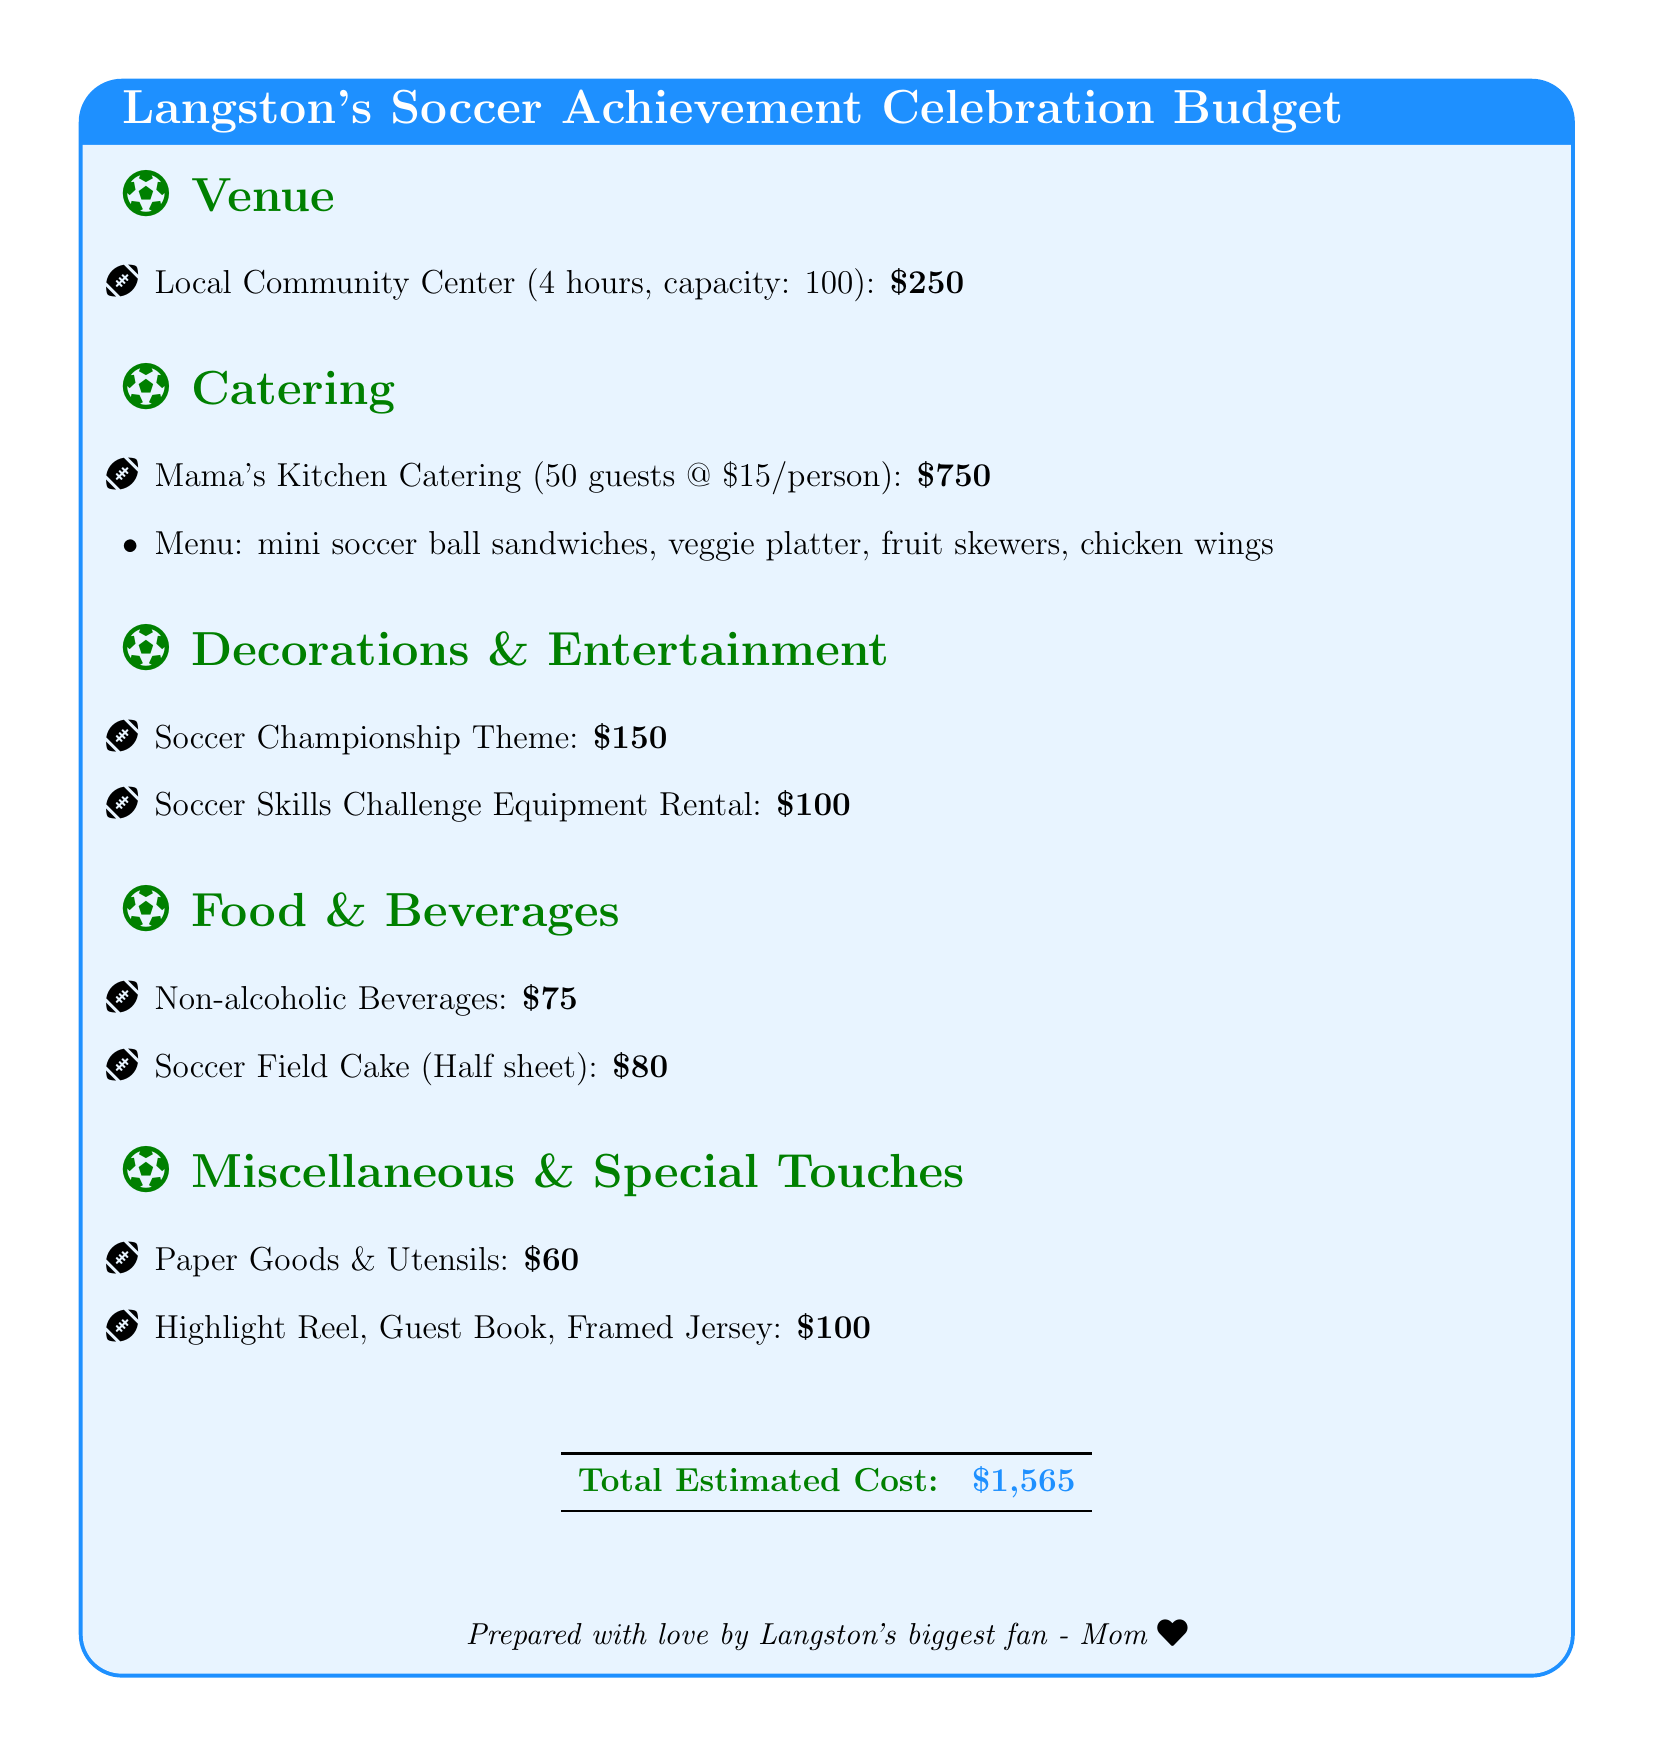What is the estimated total cost of the celebration party? The total estimated cost is listed at the bottom of the document, which aggregates all expenses.
Answer: $1,565 What venue is being rented for the celebration? The document mentions the venue for the event, which is where the celebration will be held.
Answer: Local Community Center How many guests can the venue accommodate? The document specifies the capacity of the venue, indicating how many people can attend.
Answer: 100 What is the catering cost per person? The document provides a breakdown of catering costs and indicates the price for each guest.
Answer: $15 What type of cake is being ordered? The information in the food section of the document describes the specific dessert chosen for the celebration.
Answer: Soccer Field Cake What is the cost of the Soccer Skills Challenge Equipment Rental? The breakdown lists the cost for renting equipment related to the entertainment section of the event.
Answer: $100 How much is allocated for decorations? The document specifies a budget line for various decorations required for the celebration.
Answer: $150 What special item is included in the miscellaneous section? The miscellaneous section of the document includes a few special touches that add significance to the event.
Answer: Highlight Reel Which catering service is being used? The document names the specific catering service that will provide food for the guests.
Answer: Mama's Kitchen Catering 